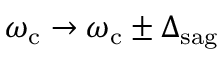<formula> <loc_0><loc_0><loc_500><loc_500>\omega _ { c } \rightarrow \omega _ { c } \pm \Delta _ { s a g }</formula> 